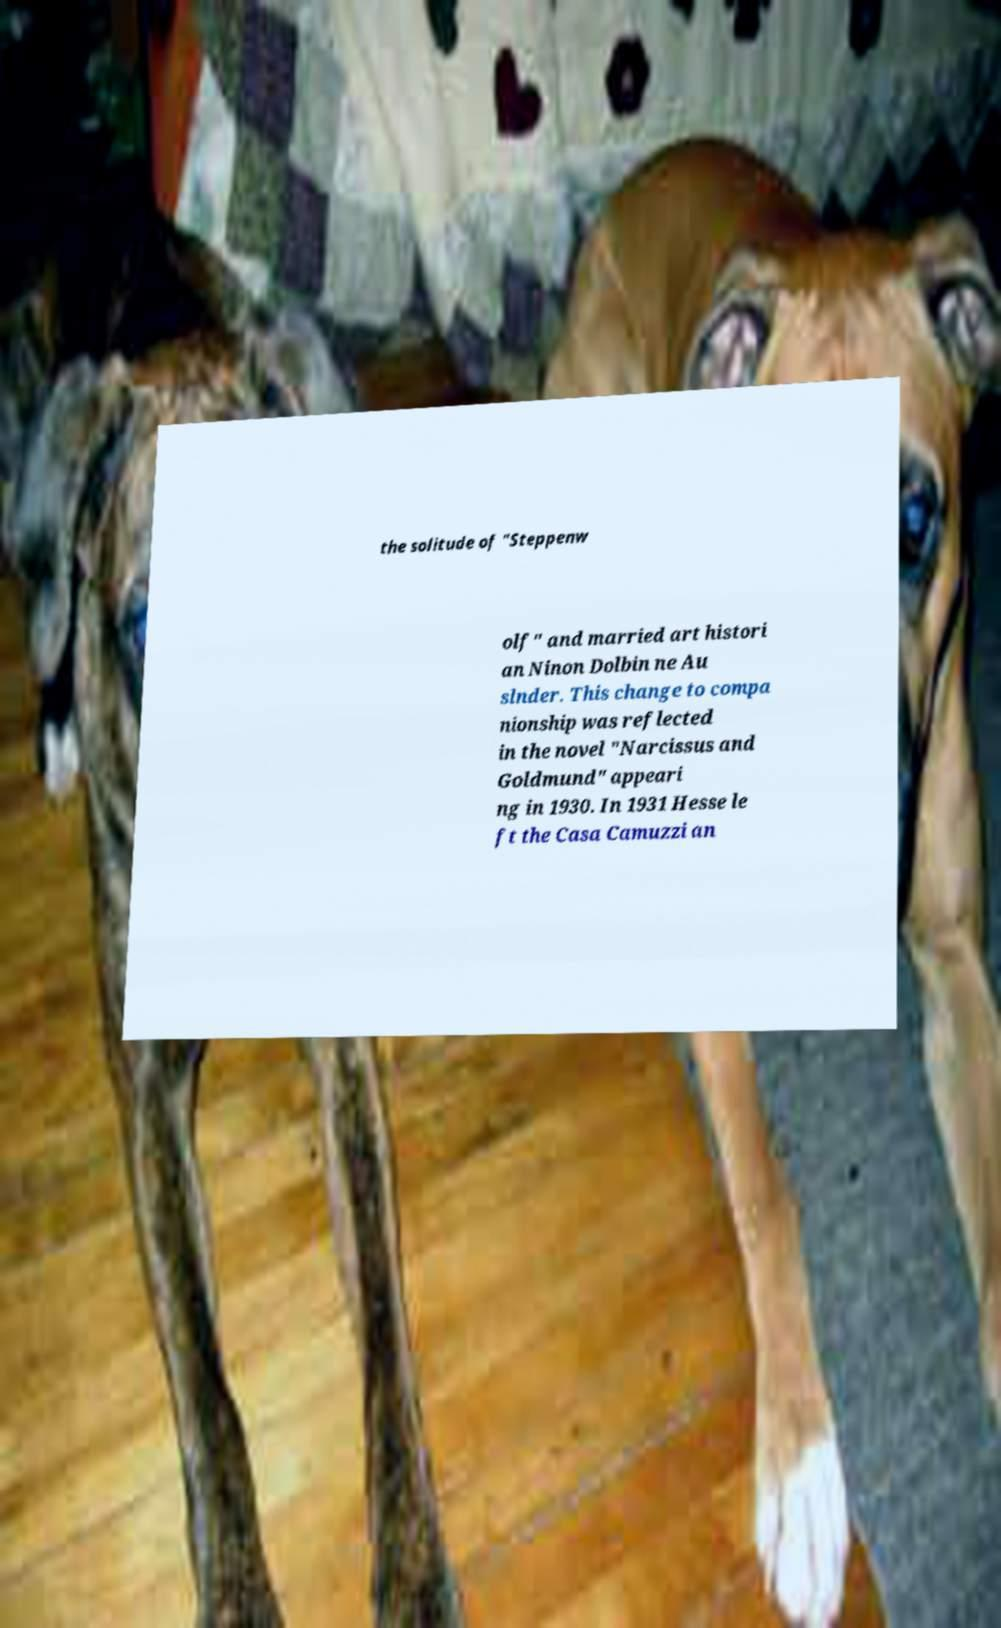Could you extract and type out the text from this image? the solitude of "Steppenw olf" and married art histori an Ninon Dolbin ne Au slnder. This change to compa nionship was reflected in the novel "Narcissus and Goldmund" appeari ng in 1930. In 1931 Hesse le ft the Casa Camuzzi an 